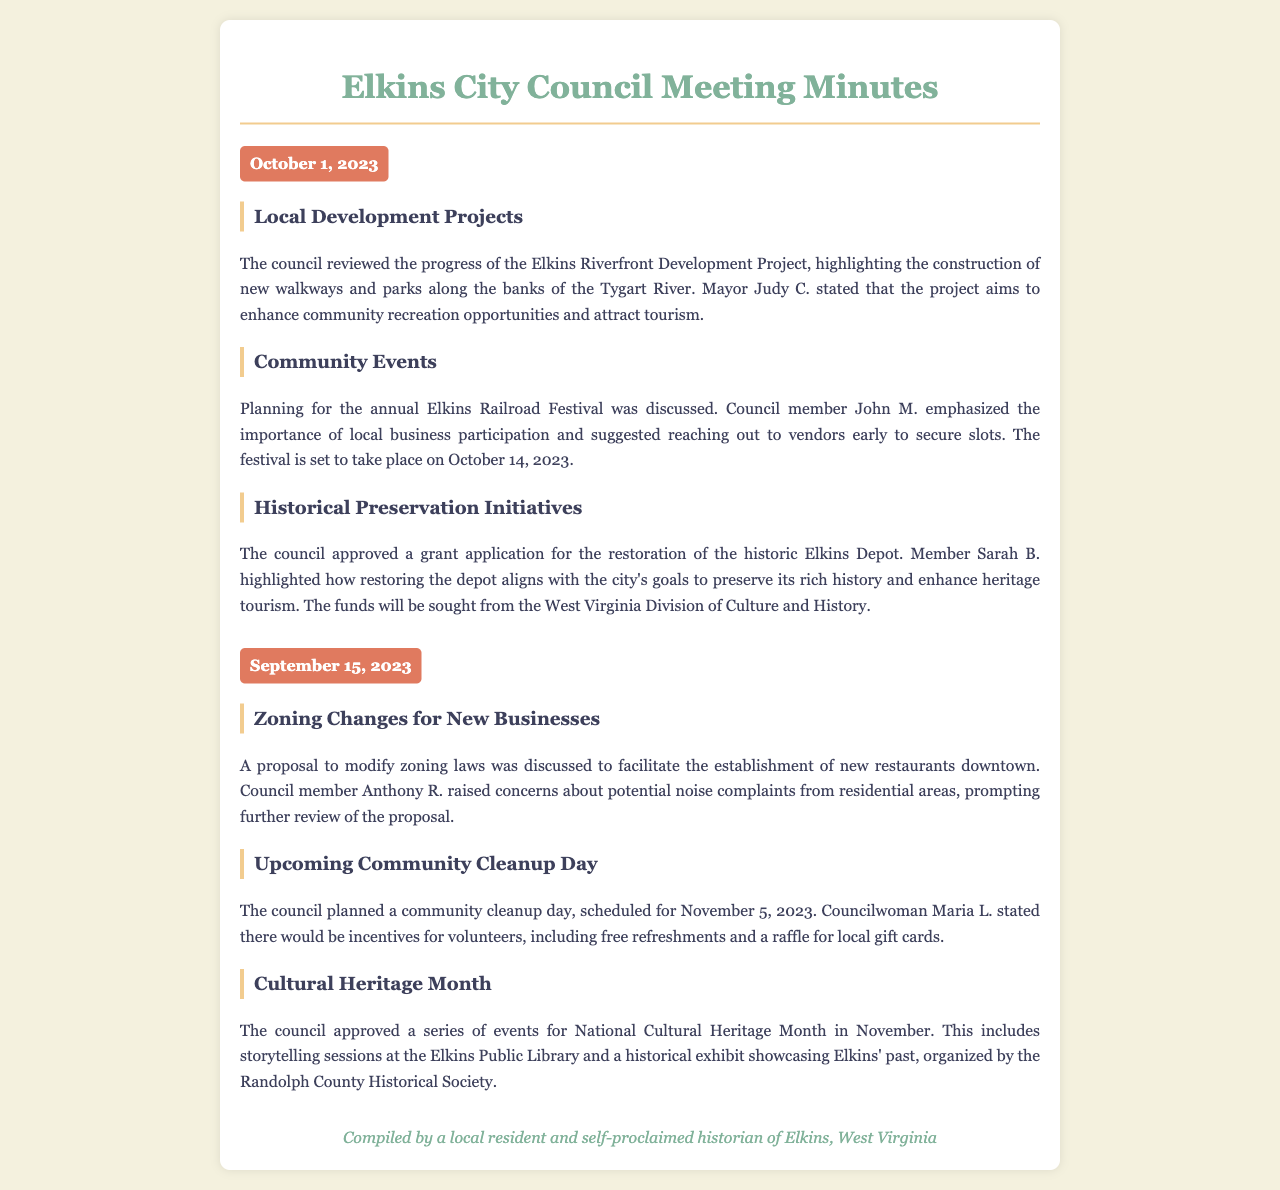What is the date of the latest council meeting? The latest council meeting was held on October 1, 2023, as indicated in the document.
Answer: October 1, 2023 Who emphasized the importance of local business participation for the Elkins Railroad Festival? Council member John M. emphasized the importance of local business participation, showing his active role in community events.
Answer: John M What project is aimed at enhancing community recreation opportunities? The Elkins Riverfront Development Project is highlighted as aimed at enhancing recreation opportunities along the Tygart River.
Answer: Elkins Riverfront Development Project When is the community cleanup day scheduled? The community cleanup day is scheduled for November 5, 2023, providing a specific date for local involvement.
Answer: November 5, 2023 What grant application did the council approve? The council approved a grant application for the restoration of the historic Elkins Depot, showcasing their commitment to historical preservation.
Answer: Restoration of the historic Elkins Depot How many events were approved for National Cultural Heritage Month? The document mentions a series (which typically implies multiple) of events for Cultural Heritage Month, involving storytelling and a historical exhibit.
Answer: Series of events What concerns were raised regarding new restaurants in downtown? Council member Anthony R. raised concerns about potential noise complaints, reflecting a need for balance in development.
Answer: Noise complaints What incentives were mentioned for volunteers participating in the cleanup day? There would be free refreshments and a raffle for local gift cards provided as incentives for volunteers' participation.
Answer: Free refreshments and a raffle for local gift cards 